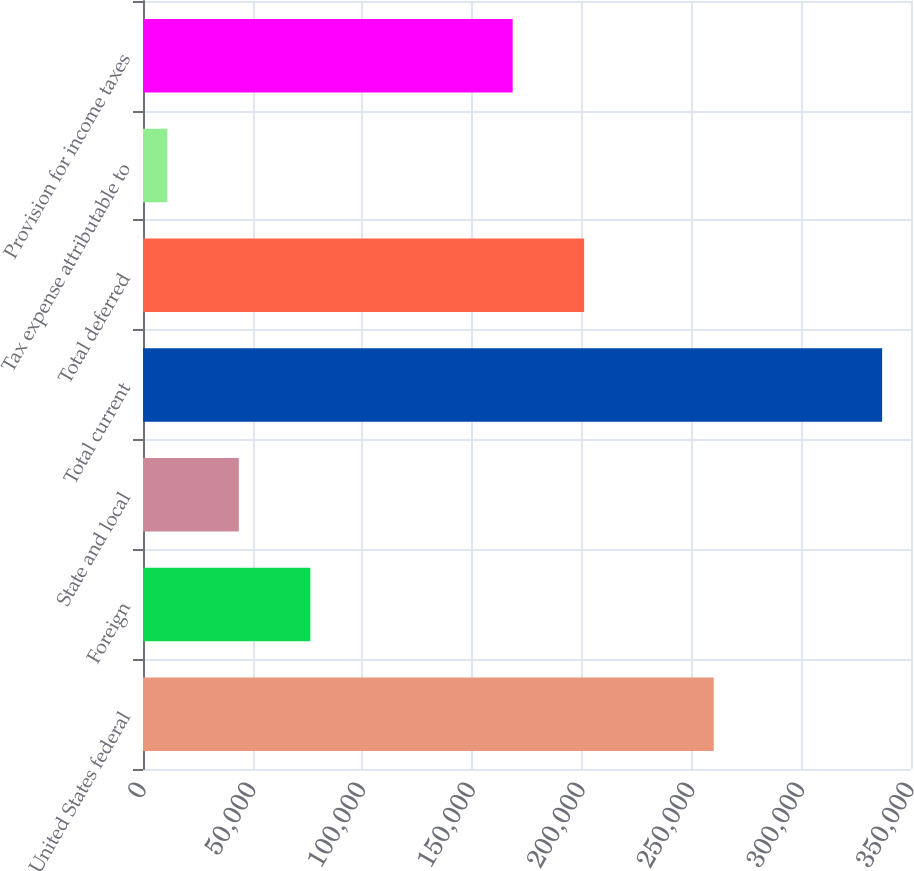<chart> <loc_0><loc_0><loc_500><loc_500><bar_chart><fcel>United States federal<fcel>Foreign<fcel>State and local<fcel>Total current<fcel>Total deferred<fcel>Tax expense attributable to<fcel>Provision for income taxes<nl><fcel>260118<fcel>76257<fcel>43682.5<fcel>336853<fcel>201046<fcel>11108<fcel>168471<nl></chart> 